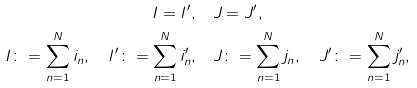<formula> <loc_0><loc_0><loc_500><loc_500>I = I ^ { \prime } , & \quad J = J ^ { \prime } , \\ I \colon = \sum _ { n = 1 } ^ { N } i _ { n } , \quad I ^ { \prime } \colon = \sum _ { n = 1 } ^ { N } i ^ { \prime } _ { n } , & \quad J \colon = \sum _ { n = 1 } ^ { N } j _ { n } , \quad J ^ { \prime } \colon = \sum _ { n = 1 } ^ { N } j ^ { \prime } _ { n } ,</formula> 